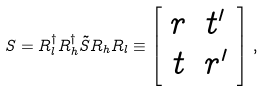Convert formula to latex. <formula><loc_0><loc_0><loc_500><loc_500>S = R ^ { \dagger } _ { l } R ^ { \dagger } _ { h } \tilde { S } R _ { h } R _ { l } \equiv \left [ \begin{array} { c c } r & t ^ { \prime } \\ t & r ^ { \prime } \end{array} \right ] \, ,</formula> 